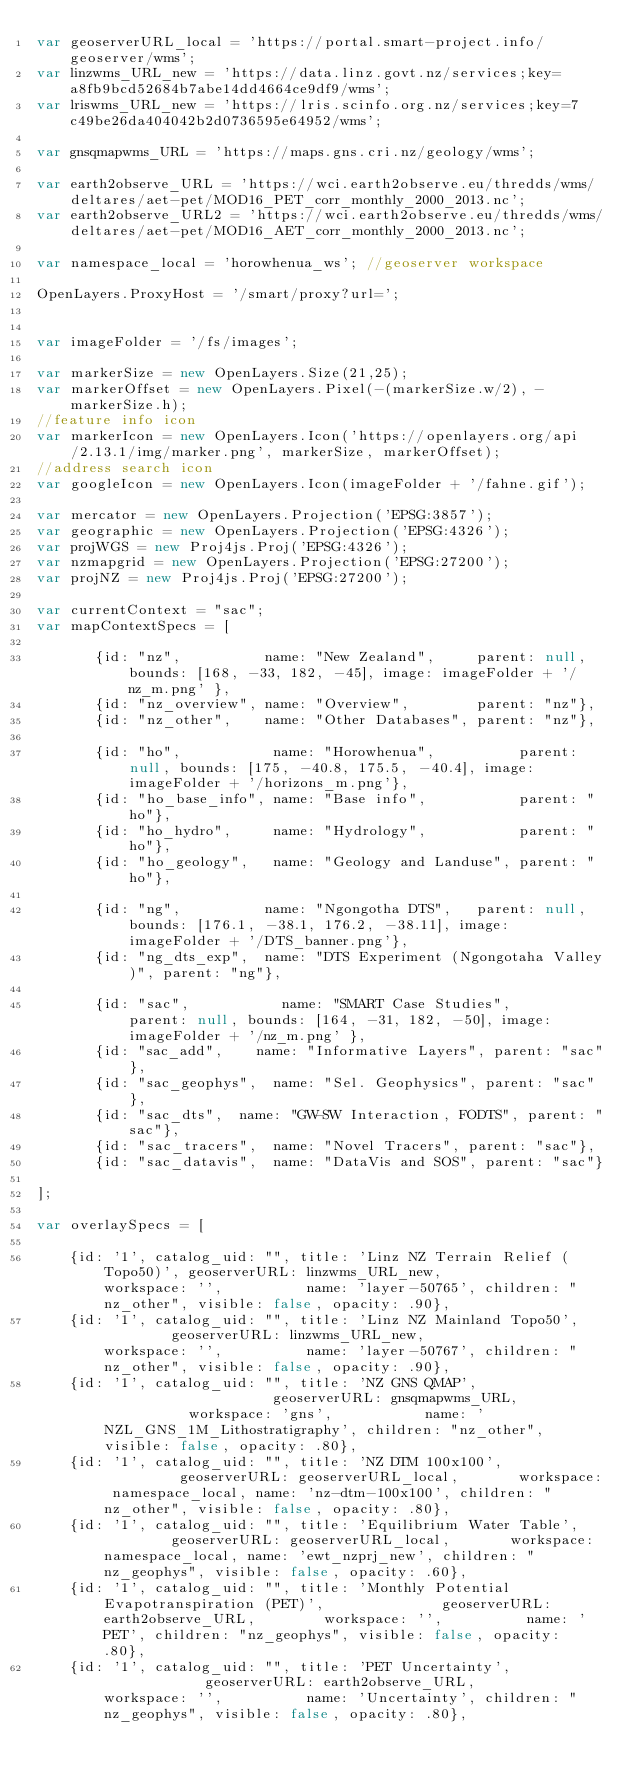Convert code to text. <code><loc_0><loc_0><loc_500><loc_500><_JavaScript_>var geoserverURL_local = 'https://portal.smart-project.info/geoserver/wms';
var linzwms_URL_new = 'https://data.linz.govt.nz/services;key=a8fb9bcd52684b7abe14dd4664ce9df9/wms';
var lriswms_URL_new = 'https://lris.scinfo.org.nz/services;key=7c49be26da404042b2d0736595e64952/wms';

var gnsqmapwms_URL = 'https://maps.gns.cri.nz/geology/wms';

var earth2observe_URL = 'https://wci.earth2observe.eu/thredds/wms/deltares/aet-pet/MOD16_PET_corr_monthly_2000_2013.nc';
var earth2observe_URL2 = 'https://wci.earth2observe.eu/thredds/wms/deltares/aet-pet/MOD16_AET_corr_monthly_2000_2013.nc';

var namespace_local = 'horowhenua_ws'; //geoserver workspace

OpenLayers.ProxyHost = '/smart/proxy?url=';


var imageFolder = '/fs/images';

var markerSize = new OpenLayers.Size(21,25);
var markerOffset = new OpenLayers.Pixel(-(markerSize.w/2), -markerSize.h);
//feature info icon
var markerIcon = new OpenLayers.Icon('https://openlayers.org/api/2.13.1/img/marker.png', markerSize, markerOffset);
//address search icon
var googleIcon = new OpenLayers.Icon(imageFolder + '/fahne.gif');

var mercator = new OpenLayers.Projection('EPSG:3857');
var geographic = new OpenLayers.Projection('EPSG:4326');
var projWGS = new Proj4js.Proj('EPSG:4326');
var nzmapgrid = new OpenLayers.Projection('EPSG:27200');
var projNZ = new Proj4js.Proj('EPSG:27200');

var currentContext = "sac";
var mapContextSpecs = [

       {id: "nz",          name: "New Zealand",     parent: null, bounds: [168, -33, 182, -45], image: imageFolder + '/nz_m.png' },
       {id: "nz_overview", name: "Overview",        parent: "nz"},
       {id: "nz_other",    name: "Other Databases", parent: "nz"},

       {id: "ho",           name: "Horowhenua",          parent: null, bounds: [175, -40.8, 175.5, -40.4], image: imageFolder + '/horizons_m.png'},
       {id: "ho_base_info", name: "Base info",           parent: "ho"},
       {id: "ho_hydro",     name: "Hydrology",           parent: "ho"},
       {id: "ho_geology",   name: "Geology and Landuse", parent: "ho"},

       {id: "ng",          name: "Ngongotha DTS",   parent: null, bounds: [176.1, -38.1, 176.2, -38.11], image: imageFolder + '/DTS_banner.png'},
       {id: "ng_dts_exp",  name: "DTS Experiment (Ngongotaha Valley)", parent: "ng"},

       {id: "sac",           name: "SMART Case Studies",          parent: null, bounds: [164, -31, 182, -50], image: imageFolder + '/nz_m.png' },
       {id: "sac_add",    name: "Informative Layers", parent: "sac"},
       {id: "sac_geophys",  name: "Sel. Geophysics", parent: "sac"},
       {id: "sac_dts",  name: "GW-SW Interaction, FODTS", parent: "sac"},
       {id: "sac_tracers",  name: "Novel Tracers", parent: "sac"},
       {id: "sac_datavis",  name: "DataVis and SOS", parent: "sac"}

];

var overlaySpecs = [

    {id: '1', catalog_uid: "", title: 'Linz NZ Terrain Relief (Topo50)', geoserverURL: linzwms_URL_new,              workspace: '',          name: 'layer-50765', children: "nz_other", visible: false, opacity: .90},
    {id: '1', catalog_uid: "", title: 'Linz NZ Mainland Topo50',         geoserverURL: linzwms_URL_new,              workspace: '',          name: 'layer-50767', children: "nz_other", visible: false, opacity: .90},
    {id: '1', catalog_uid: "", title: 'NZ GNS QMAP',                     geoserverURL: gnsqmapwms_URL,           workspace: 'gns',           name: 'NZL_GNS_1M_Lithostratigraphy', children: "nz_other", visible: false, opacity: .80},
    {id: '1', catalog_uid: "", title: 'NZ DTM 100x100',       			 geoserverURL: geoserverURL_local,       workspace: namespace_local, name: 'nz-dtm-100x100', children: "nz_other", visible: false, opacity: .80},
    {id: '1', catalog_uid: "", title: 'Equilibrium Water Table',         geoserverURL: geoserverURL_local,       workspace: namespace_local, name: 'ewt_nzprj_new', children: "nz_geophys", visible: false, opacity: .60},
    {id: '1', catalog_uid: "", title: 'Monthly Potential Evapotranspiration (PET)',         	 geoserverURL: earth2observe_URL,        workspace: '', 		 name: 'PET', children: "nz_geophys", visible: false, opacity: .80},
    {id: '1', catalog_uid: "", title: 'PET Uncertainty',         	 geoserverURL: earth2observe_URL,        workspace: '', 		 name: 'Uncertainty', children: "nz_geophys", visible: false, opacity: .80},</code> 